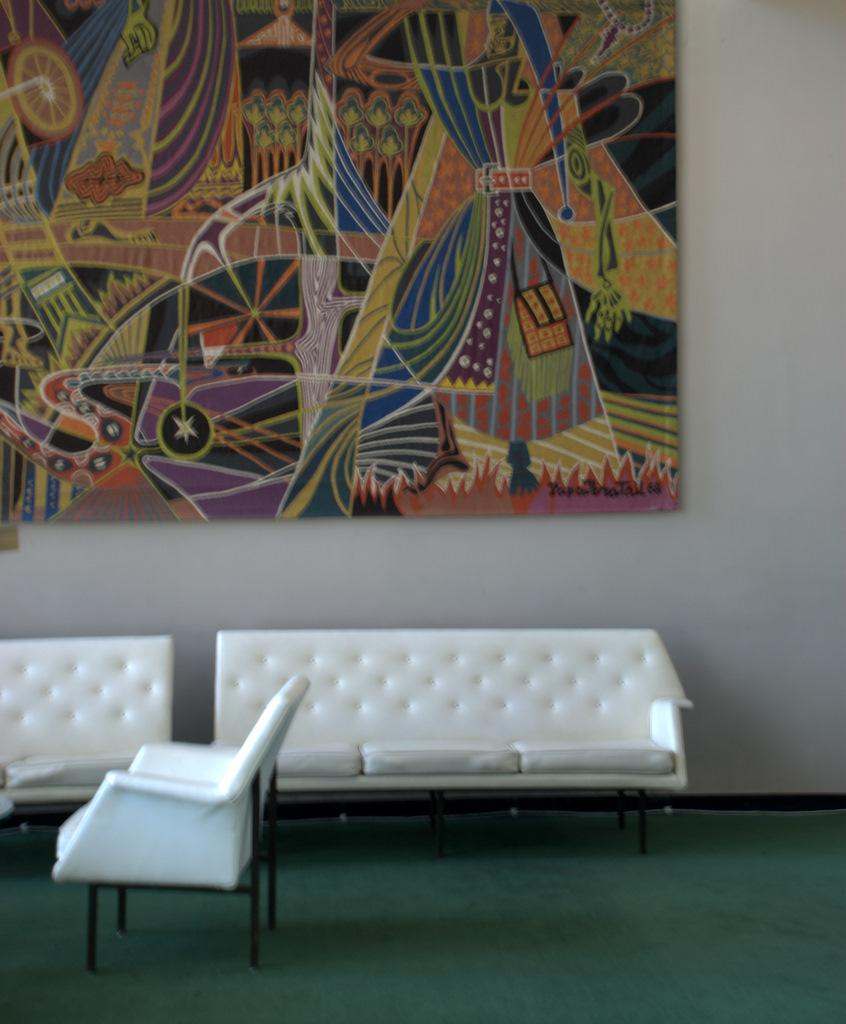What type of furniture is present in the image? There are sofas and a chair on the floor in the image. What can be seen in the background of the image? There is a wall and a painting board in the background of the image. What type of tooth is visible on the painting board in the image? There is no tooth present on the painting board in the image. What type of society is depicted in the image? The image does not depict any society; it shows furniture and a painting board in a room. 